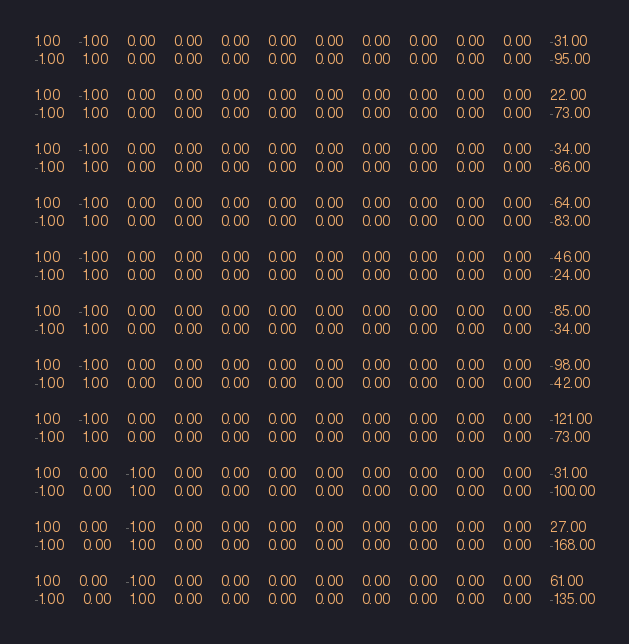Convert code to text. <code><loc_0><loc_0><loc_500><loc_500><_Matlab_>1.00	-1.00	0.00	0.00	0.00	0.00	0.00	0.00	0.00	0.00	0.00	-31.00
-1.00	1.00	0.00	0.00	0.00	0.00	0.00	0.00	0.00	0.00	0.00	-95.00

1.00	-1.00	0.00	0.00	0.00	0.00	0.00	0.00	0.00	0.00	0.00	22.00
-1.00	1.00	0.00	0.00	0.00	0.00	0.00	0.00	0.00	0.00	0.00	-73.00

1.00	-1.00	0.00	0.00	0.00	0.00	0.00	0.00	0.00	0.00	0.00	-34.00
-1.00	1.00	0.00	0.00	0.00	0.00	0.00	0.00	0.00	0.00	0.00	-86.00

1.00	-1.00	0.00	0.00	0.00	0.00	0.00	0.00	0.00	0.00	0.00	-64.00
-1.00	1.00	0.00	0.00	0.00	0.00	0.00	0.00	0.00	0.00	0.00	-83.00

1.00	-1.00	0.00	0.00	0.00	0.00	0.00	0.00	0.00	0.00	0.00	-46.00
-1.00	1.00	0.00	0.00	0.00	0.00	0.00	0.00	0.00	0.00	0.00	-24.00

1.00	-1.00	0.00	0.00	0.00	0.00	0.00	0.00	0.00	0.00	0.00	-85.00
-1.00	1.00	0.00	0.00	0.00	0.00	0.00	0.00	0.00	0.00	0.00	-34.00

1.00	-1.00	0.00	0.00	0.00	0.00	0.00	0.00	0.00	0.00	0.00	-98.00
-1.00	1.00	0.00	0.00	0.00	0.00	0.00	0.00	0.00	0.00	0.00	-42.00

1.00	-1.00	0.00	0.00	0.00	0.00	0.00	0.00	0.00	0.00	0.00	-121.00
-1.00	1.00	0.00	0.00	0.00	0.00	0.00	0.00	0.00	0.00	0.00	-73.00

1.00	0.00	-1.00	0.00	0.00	0.00	0.00	0.00	0.00	0.00	0.00	-31.00
-1.00	0.00	1.00	0.00	0.00	0.00	0.00	0.00	0.00	0.00	0.00	-100.00

1.00	0.00	-1.00	0.00	0.00	0.00	0.00	0.00	0.00	0.00	0.00	27.00
-1.00	0.00	1.00	0.00	0.00	0.00	0.00	0.00	0.00	0.00	0.00	-168.00

1.00	0.00	-1.00	0.00	0.00	0.00	0.00	0.00	0.00	0.00	0.00	61.00
-1.00	0.00	1.00	0.00	0.00	0.00	0.00	0.00	0.00	0.00	0.00	-135.00
</code> 